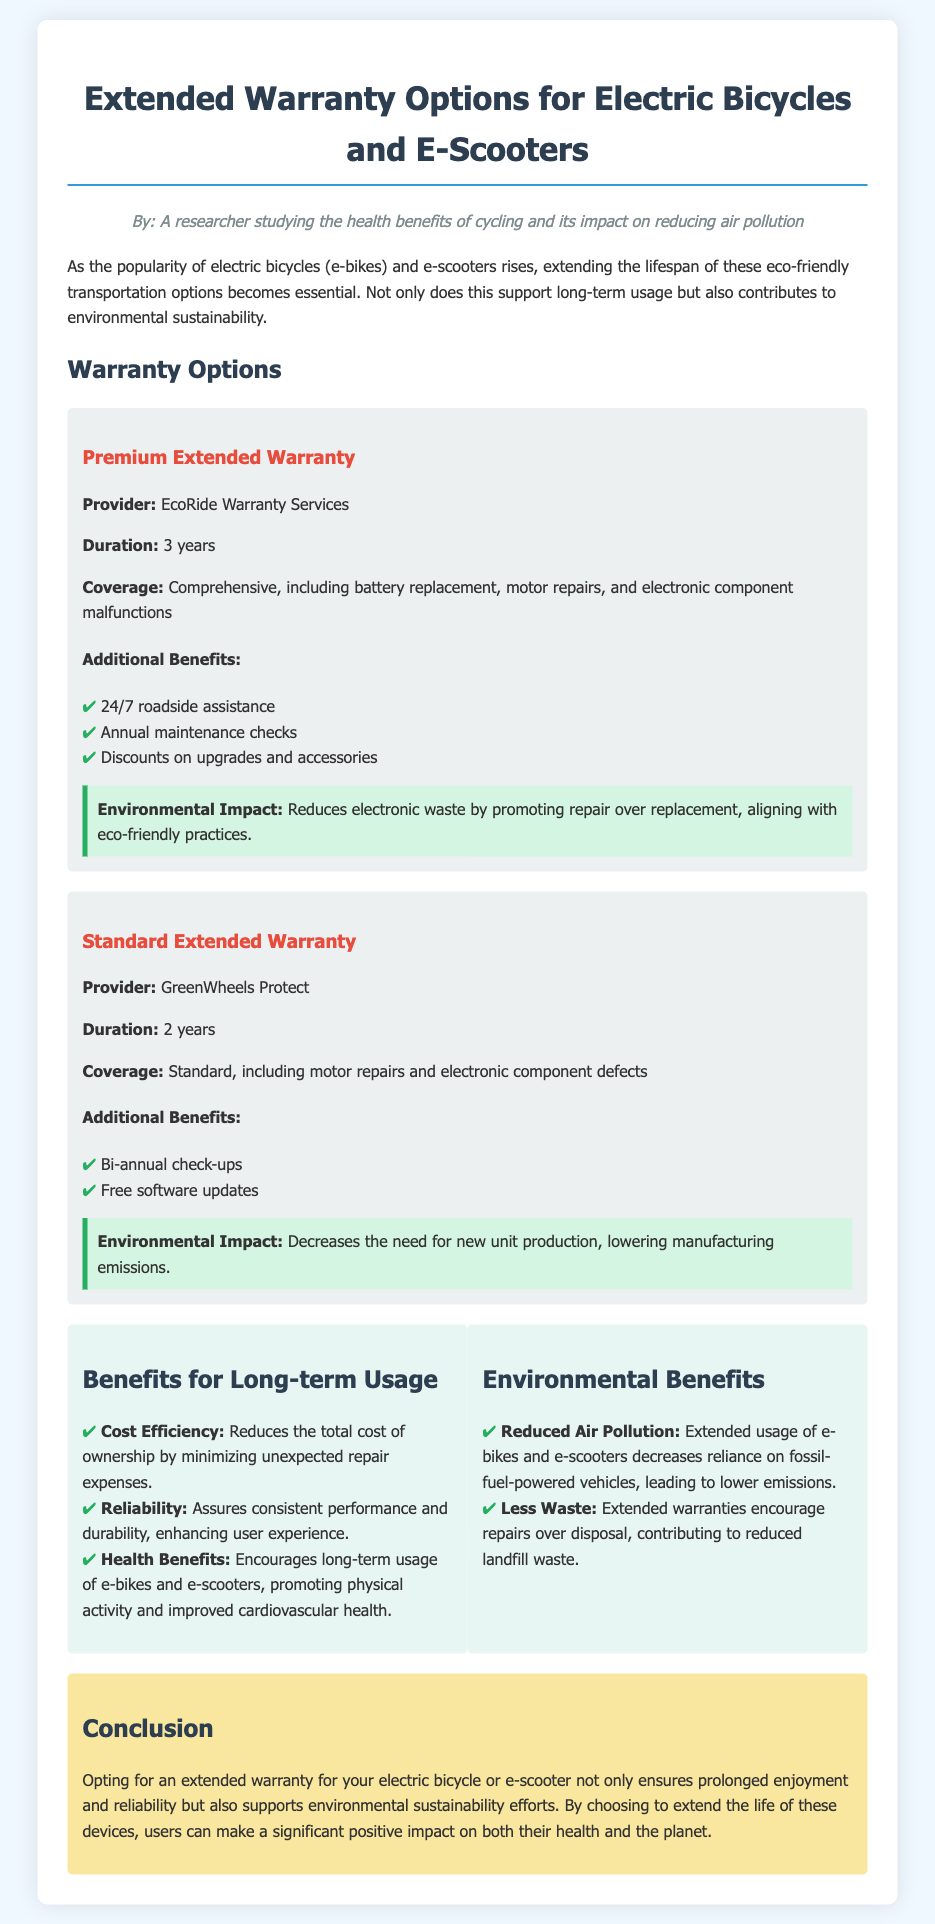What is the provider of the Premium Extended Warranty? The provider is mentioned in the section about the Premium Extended Warranty.
Answer: EcoRide Warranty Services What is the duration of the Standard Extended Warranty? The duration is specified in the description of the Standard Extended Warranty.
Answer: 2 years What additional benefit is provided with the Premium Extended Warranty? The benefits listed under the Premium Extended Warranty include various services.
Answer: 24/7 roadside assistance What is covered under the Premium Extended Warranty? The coverage details for the Premium Extended Warranty are stated in the document.
Answer: Comprehensive, including battery replacement, motor repairs, and electronic component malfunctions How does extending the usage of e-bikes reduce air pollution? The document states how extended usage impacts vehicle reliance and emissions.
Answer: Decreases reliance on fossil-fuel-powered vehicles What is one health benefit of long-term usage of e-bikes and e-scooters? The document lists various health benefits associated with cycling and e-scooter usage.
Answer: Improved cardiovascular health What type of warranty is offered for both electric bicycles and e-scooters? The document provides a specific type of extended warranty available for both vehicles.
Answer: Extended Warranty What does the environmental impact of the Standard Extended Warranty promote? The document discusses the environmental impact related to the Standard Extended Warranty.
Answer: Decreases the need for new unit production 